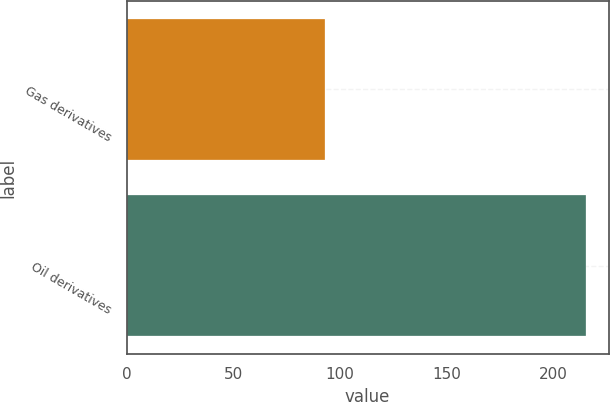<chart> <loc_0><loc_0><loc_500><loc_500><bar_chart><fcel>Gas derivatives<fcel>Oil derivatives<nl><fcel>93<fcel>215<nl></chart> 